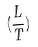<formula> <loc_0><loc_0><loc_500><loc_500>( \frac { L } { T } )</formula> 